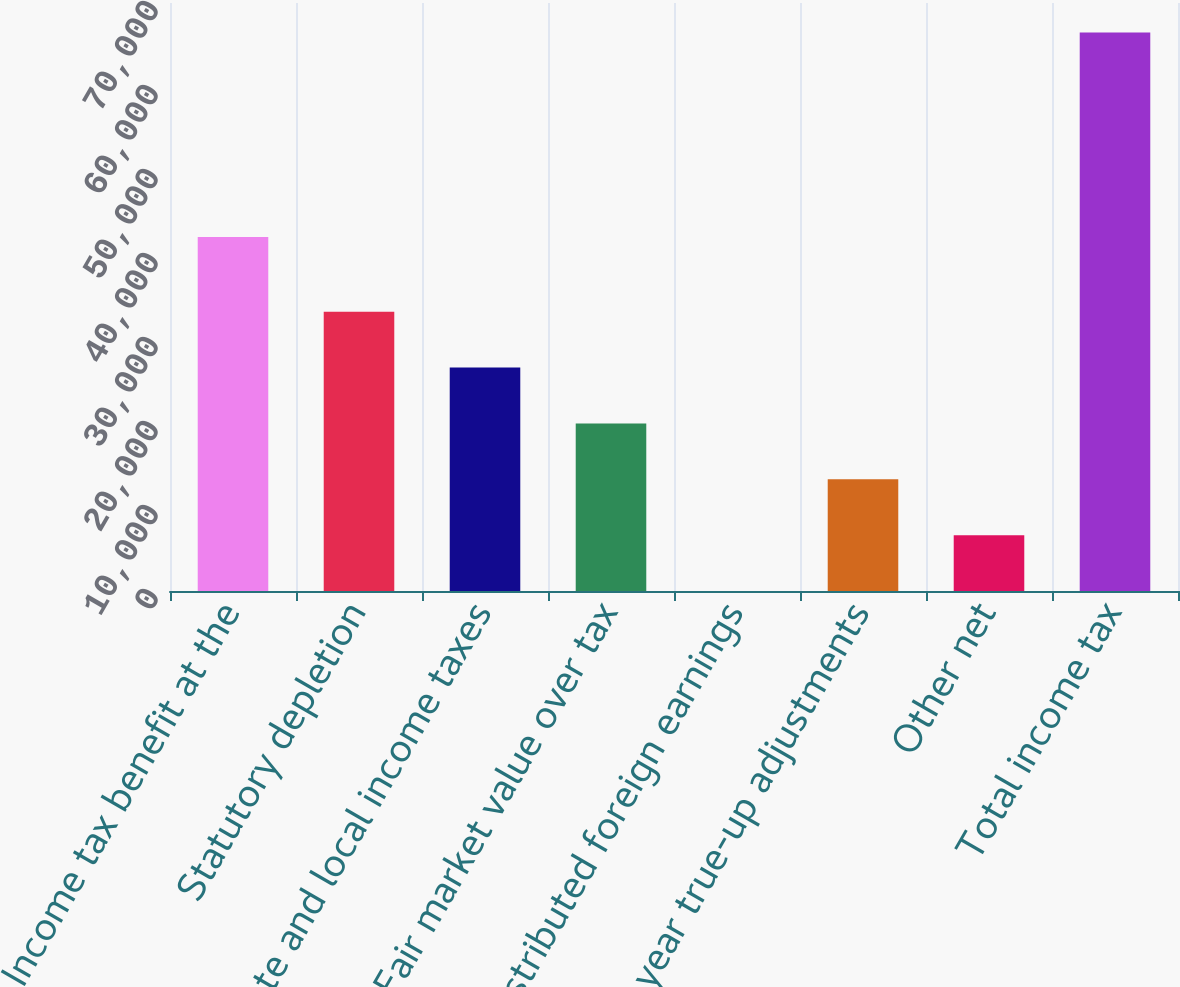Convert chart. <chart><loc_0><loc_0><loc_500><loc_500><bar_chart><fcel>Income tax benefit at the<fcel>Statutory depletion<fcel>State and local income taxes<fcel>Fair market value over tax<fcel>Undistributed foreign earnings<fcel>Prior year true-up adjustments<fcel>Other net<fcel>Total income tax<nl><fcel>42146<fcel>33246.3<fcel>26597.2<fcel>19948<fcel>0.55<fcel>13298.9<fcel>6649.7<fcel>66492<nl></chart> 